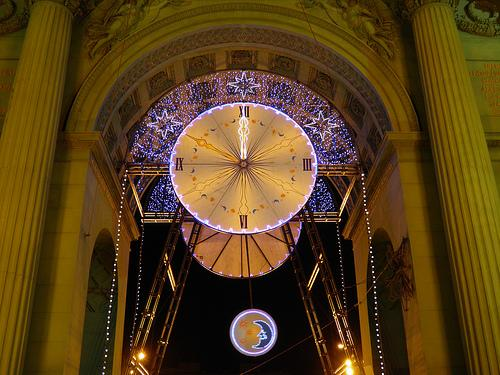Which object forms the core of the image and what aspects make it captivating? The core of the image is the round golden clockface, captivating with its roman numerals, sun and moon motif, and illuminations. Identify the primary object in the image and describe its visual appeal. The main object is a vibrant golden clockface with roman numerals, creating a vintage and elegant atmosphere. Point out the key element in the image and explain what makes it stand out. The key element is a round golden clock with roman numerals, catching the eye with its unique design and lighting. Highlight the central object in the image and describe its main characteristics. The central object is the golden clockface, featuring roman numerals, ornate decorations, and being prominently displayed under an arch. What is the main subject of the image and give a brief account of its appearance. The main subject is an ornate golden clock face hanging under an arch, surrounded by festive lights and decorations. Mention one striking feature of the image and give a concise description. A festive clock with a golden face and roman numerals suspended under an arch with illuminations. Provide a brief description of the most prominent object in the image. A round golden clockface with roman numerals suspended from an archway. Identify the focal point of the image and briefly describe its most noteworthy features. The focal point is the round, festive golden clockface with roman numerals, which is elegantly suspended from an arch and surrounded by beautiful decorations. What is the most eye-catching element in the image and how does it appear? The round golden clockface with roman numerals stands out as it is suspended from an arch and illuminated. What is the central focus of the image and what aspects make it interesting? The central focus is an ornate golden clockface under an arch, with a sun and moon motif and illuminations. 